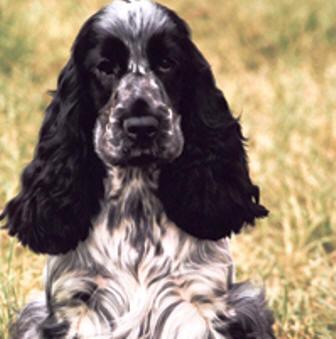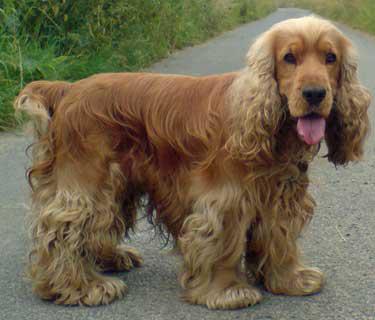The first image is the image on the left, the second image is the image on the right. Assess this claim about the two images: "One dog's body is turned towards the right.". Correct or not? Answer yes or no. Yes. The first image is the image on the left, the second image is the image on the right. Examine the images to the left and right. Is the description "The right image features one orange cocker spaniel standing on all fours in profile, and the left image features a spaniel with dark fur on the ears and eyes and lighter body fur." accurate? Answer yes or no. Yes. 